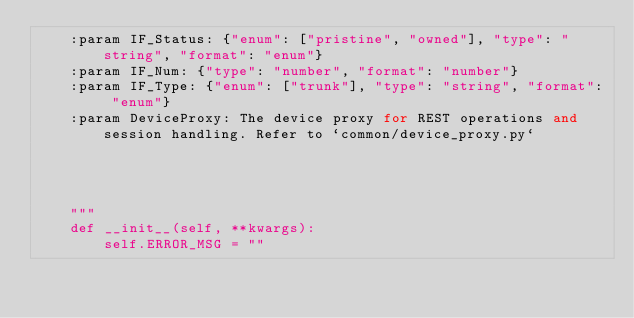Convert code to text. <code><loc_0><loc_0><loc_500><loc_500><_Python_>    :param IF_Status: {"enum": ["pristine", "owned"], "type": "string", "format": "enum"}
    :param IF_Num: {"type": "number", "format": "number"}
    :param IF_Type: {"enum": ["trunk"], "type": "string", "format": "enum"}
    :param DeviceProxy: The device proxy for REST operations and session handling. Refer to `common/device_proxy.py`

    

    
    """
    def __init__(self, **kwargs):
        self.ERROR_MSG = ""
        </code> 